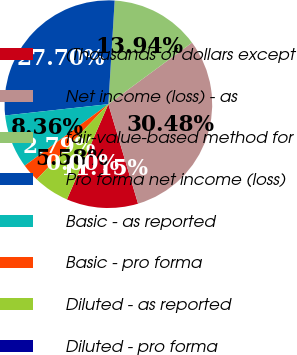Convert chart. <chart><loc_0><loc_0><loc_500><loc_500><pie_chart><fcel>(Thousands of dollars except<fcel>Net income (loss) - as<fcel>fair-value-based method for<fcel>Pro forma net income (loss)<fcel>Basic - as reported<fcel>Basic - pro forma<fcel>Diluted - as reported<fcel>Diluted - pro forma<nl><fcel>11.15%<fcel>30.48%<fcel>13.94%<fcel>27.7%<fcel>8.36%<fcel>2.79%<fcel>5.58%<fcel>0.0%<nl></chart> 